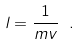<formula> <loc_0><loc_0><loc_500><loc_500>l = \frac { 1 } { m v } \ .</formula> 